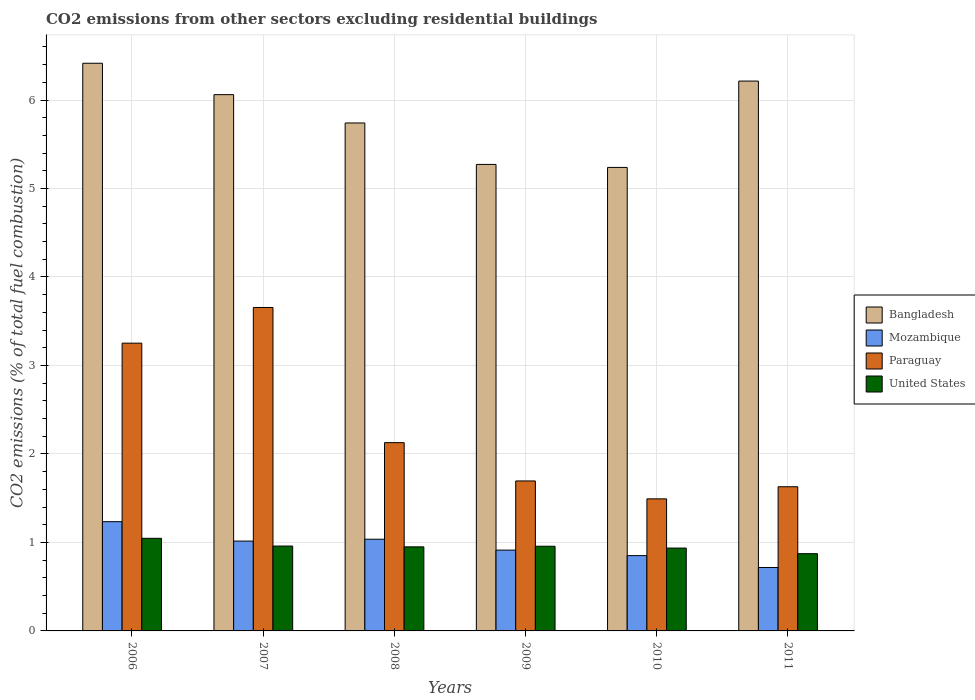How many groups of bars are there?
Give a very brief answer. 6. Are the number of bars per tick equal to the number of legend labels?
Make the answer very short. Yes. What is the label of the 1st group of bars from the left?
Your answer should be very brief. 2006. In how many cases, is the number of bars for a given year not equal to the number of legend labels?
Provide a succinct answer. 0. What is the total CO2 emitted in Bangladesh in 2010?
Your answer should be very brief. 5.24. Across all years, what is the maximum total CO2 emitted in Paraguay?
Provide a succinct answer. 3.66. Across all years, what is the minimum total CO2 emitted in Bangladesh?
Your response must be concise. 5.24. What is the total total CO2 emitted in Mozambique in the graph?
Your answer should be very brief. 5.77. What is the difference between the total CO2 emitted in Paraguay in 2007 and that in 2008?
Your answer should be compact. 1.53. What is the difference between the total CO2 emitted in Bangladesh in 2010 and the total CO2 emitted in United States in 2009?
Your response must be concise. 4.28. What is the average total CO2 emitted in Bangladesh per year?
Offer a very short reply. 5.82. In the year 2011, what is the difference between the total CO2 emitted in Bangladesh and total CO2 emitted in Paraguay?
Provide a succinct answer. 4.58. In how many years, is the total CO2 emitted in United States greater than 5?
Provide a succinct answer. 0. What is the ratio of the total CO2 emitted in Bangladesh in 2008 to that in 2009?
Give a very brief answer. 1.09. Is the total CO2 emitted in Bangladesh in 2006 less than that in 2011?
Keep it short and to the point. No. Is the difference between the total CO2 emitted in Bangladesh in 2007 and 2009 greater than the difference between the total CO2 emitted in Paraguay in 2007 and 2009?
Keep it short and to the point. No. What is the difference between the highest and the second highest total CO2 emitted in United States?
Your answer should be compact. 0.09. What is the difference between the highest and the lowest total CO2 emitted in United States?
Offer a terse response. 0.17. Is it the case that in every year, the sum of the total CO2 emitted in United States and total CO2 emitted in Paraguay is greater than the sum of total CO2 emitted in Bangladesh and total CO2 emitted in Mozambique?
Your response must be concise. No. What does the 1st bar from the left in 2011 represents?
Make the answer very short. Bangladesh. What does the 3rd bar from the right in 2007 represents?
Offer a very short reply. Mozambique. Is it the case that in every year, the sum of the total CO2 emitted in Paraguay and total CO2 emitted in Bangladesh is greater than the total CO2 emitted in Mozambique?
Your answer should be very brief. Yes. How many years are there in the graph?
Ensure brevity in your answer.  6. Are the values on the major ticks of Y-axis written in scientific E-notation?
Give a very brief answer. No. Does the graph contain grids?
Your answer should be very brief. Yes. How are the legend labels stacked?
Offer a very short reply. Vertical. What is the title of the graph?
Make the answer very short. CO2 emissions from other sectors excluding residential buildings. Does "Sao Tome and Principe" appear as one of the legend labels in the graph?
Offer a terse response. No. What is the label or title of the X-axis?
Keep it short and to the point. Years. What is the label or title of the Y-axis?
Give a very brief answer. CO2 emissions (% of total fuel combustion). What is the CO2 emissions (% of total fuel combustion) in Bangladesh in 2006?
Give a very brief answer. 6.42. What is the CO2 emissions (% of total fuel combustion) of Mozambique in 2006?
Give a very brief answer. 1.23. What is the CO2 emissions (% of total fuel combustion) in Paraguay in 2006?
Make the answer very short. 3.25. What is the CO2 emissions (% of total fuel combustion) of United States in 2006?
Provide a succinct answer. 1.05. What is the CO2 emissions (% of total fuel combustion) in Bangladesh in 2007?
Give a very brief answer. 6.06. What is the CO2 emissions (% of total fuel combustion) in Mozambique in 2007?
Your response must be concise. 1.02. What is the CO2 emissions (% of total fuel combustion) in Paraguay in 2007?
Keep it short and to the point. 3.66. What is the CO2 emissions (% of total fuel combustion) of United States in 2007?
Ensure brevity in your answer.  0.96. What is the CO2 emissions (% of total fuel combustion) in Bangladesh in 2008?
Offer a terse response. 5.74. What is the CO2 emissions (% of total fuel combustion) in Mozambique in 2008?
Ensure brevity in your answer.  1.04. What is the CO2 emissions (% of total fuel combustion) in Paraguay in 2008?
Your answer should be very brief. 2.13. What is the CO2 emissions (% of total fuel combustion) in United States in 2008?
Keep it short and to the point. 0.95. What is the CO2 emissions (% of total fuel combustion) in Bangladesh in 2009?
Ensure brevity in your answer.  5.27. What is the CO2 emissions (% of total fuel combustion) of Mozambique in 2009?
Ensure brevity in your answer.  0.91. What is the CO2 emissions (% of total fuel combustion) in Paraguay in 2009?
Your answer should be compact. 1.69. What is the CO2 emissions (% of total fuel combustion) in United States in 2009?
Make the answer very short. 0.96. What is the CO2 emissions (% of total fuel combustion) in Bangladesh in 2010?
Offer a very short reply. 5.24. What is the CO2 emissions (% of total fuel combustion) of Mozambique in 2010?
Provide a succinct answer. 0.85. What is the CO2 emissions (% of total fuel combustion) in Paraguay in 2010?
Your answer should be compact. 1.49. What is the CO2 emissions (% of total fuel combustion) of United States in 2010?
Keep it short and to the point. 0.94. What is the CO2 emissions (% of total fuel combustion) in Bangladesh in 2011?
Keep it short and to the point. 6.21. What is the CO2 emissions (% of total fuel combustion) of Mozambique in 2011?
Your response must be concise. 0.72. What is the CO2 emissions (% of total fuel combustion) in Paraguay in 2011?
Give a very brief answer. 1.63. What is the CO2 emissions (% of total fuel combustion) in United States in 2011?
Offer a terse response. 0.87. Across all years, what is the maximum CO2 emissions (% of total fuel combustion) in Bangladesh?
Provide a succinct answer. 6.42. Across all years, what is the maximum CO2 emissions (% of total fuel combustion) in Mozambique?
Offer a very short reply. 1.23. Across all years, what is the maximum CO2 emissions (% of total fuel combustion) in Paraguay?
Give a very brief answer. 3.66. Across all years, what is the maximum CO2 emissions (% of total fuel combustion) in United States?
Provide a succinct answer. 1.05. Across all years, what is the minimum CO2 emissions (% of total fuel combustion) of Bangladesh?
Keep it short and to the point. 5.24. Across all years, what is the minimum CO2 emissions (% of total fuel combustion) of Mozambique?
Offer a very short reply. 0.72. Across all years, what is the minimum CO2 emissions (% of total fuel combustion) in Paraguay?
Give a very brief answer. 1.49. Across all years, what is the minimum CO2 emissions (% of total fuel combustion) of United States?
Make the answer very short. 0.87. What is the total CO2 emissions (% of total fuel combustion) in Bangladesh in the graph?
Give a very brief answer. 34.94. What is the total CO2 emissions (% of total fuel combustion) in Mozambique in the graph?
Offer a very short reply. 5.77. What is the total CO2 emissions (% of total fuel combustion) of Paraguay in the graph?
Keep it short and to the point. 13.85. What is the total CO2 emissions (% of total fuel combustion) in United States in the graph?
Give a very brief answer. 5.72. What is the difference between the CO2 emissions (% of total fuel combustion) in Bangladesh in 2006 and that in 2007?
Your answer should be very brief. 0.35. What is the difference between the CO2 emissions (% of total fuel combustion) in Mozambique in 2006 and that in 2007?
Provide a succinct answer. 0.22. What is the difference between the CO2 emissions (% of total fuel combustion) in Paraguay in 2006 and that in 2007?
Your answer should be very brief. -0.4. What is the difference between the CO2 emissions (% of total fuel combustion) of United States in 2006 and that in 2007?
Your answer should be very brief. 0.09. What is the difference between the CO2 emissions (% of total fuel combustion) of Bangladesh in 2006 and that in 2008?
Your answer should be very brief. 0.67. What is the difference between the CO2 emissions (% of total fuel combustion) in Mozambique in 2006 and that in 2008?
Provide a succinct answer. 0.2. What is the difference between the CO2 emissions (% of total fuel combustion) of Paraguay in 2006 and that in 2008?
Give a very brief answer. 1.12. What is the difference between the CO2 emissions (% of total fuel combustion) of United States in 2006 and that in 2008?
Provide a succinct answer. 0.1. What is the difference between the CO2 emissions (% of total fuel combustion) of Bangladesh in 2006 and that in 2009?
Provide a succinct answer. 1.14. What is the difference between the CO2 emissions (% of total fuel combustion) in Mozambique in 2006 and that in 2009?
Your answer should be very brief. 0.32. What is the difference between the CO2 emissions (% of total fuel combustion) in Paraguay in 2006 and that in 2009?
Make the answer very short. 1.56. What is the difference between the CO2 emissions (% of total fuel combustion) in United States in 2006 and that in 2009?
Make the answer very short. 0.09. What is the difference between the CO2 emissions (% of total fuel combustion) in Bangladesh in 2006 and that in 2010?
Give a very brief answer. 1.18. What is the difference between the CO2 emissions (% of total fuel combustion) in Mozambique in 2006 and that in 2010?
Your response must be concise. 0.38. What is the difference between the CO2 emissions (% of total fuel combustion) in Paraguay in 2006 and that in 2010?
Ensure brevity in your answer.  1.76. What is the difference between the CO2 emissions (% of total fuel combustion) in United States in 2006 and that in 2010?
Your answer should be compact. 0.11. What is the difference between the CO2 emissions (% of total fuel combustion) of Bangladesh in 2006 and that in 2011?
Ensure brevity in your answer.  0.2. What is the difference between the CO2 emissions (% of total fuel combustion) in Mozambique in 2006 and that in 2011?
Your response must be concise. 0.52. What is the difference between the CO2 emissions (% of total fuel combustion) of Paraguay in 2006 and that in 2011?
Your answer should be very brief. 1.62. What is the difference between the CO2 emissions (% of total fuel combustion) in United States in 2006 and that in 2011?
Keep it short and to the point. 0.17. What is the difference between the CO2 emissions (% of total fuel combustion) in Bangladesh in 2007 and that in 2008?
Provide a succinct answer. 0.32. What is the difference between the CO2 emissions (% of total fuel combustion) in Mozambique in 2007 and that in 2008?
Your answer should be very brief. -0.02. What is the difference between the CO2 emissions (% of total fuel combustion) in Paraguay in 2007 and that in 2008?
Make the answer very short. 1.53. What is the difference between the CO2 emissions (% of total fuel combustion) in United States in 2007 and that in 2008?
Keep it short and to the point. 0.01. What is the difference between the CO2 emissions (% of total fuel combustion) in Bangladesh in 2007 and that in 2009?
Offer a terse response. 0.79. What is the difference between the CO2 emissions (% of total fuel combustion) of Mozambique in 2007 and that in 2009?
Your answer should be very brief. 0.1. What is the difference between the CO2 emissions (% of total fuel combustion) of Paraguay in 2007 and that in 2009?
Make the answer very short. 1.96. What is the difference between the CO2 emissions (% of total fuel combustion) in United States in 2007 and that in 2009?
Give a very brief answer. 0. What is the difference between the CO2 emissions (% of total fuel combustion) of Bangladesh in 2007 and that in 2010?
Provide a short and direct response. 0.82. What is the difference between the CO2 emissions (% of total fuel combustion) of Mozambique in 2007 and that in 2010?
Your answer should be very brief. 0.16. What is the difference between the CO2 emissions (% of total fuel combustion) of Paraguay in 2007 and that in 2010?
Your answer should be very brief. 2.16. What is the difference between the CO2 emissions (% of total fuel combustion) in United States in 2007 and that in 2010?
Make the answer very short. 0.02. What is the difference between the CO2 emissions (% of total fuel combustion) in Bangladesh in 2007 and that in 2011?
Make the answer very short. -0.15. What is the difference between the CO2 emissions (% of total fuel combustion) of Mozambique in 2007 and that in 2011?
Your answer should be very brief. 0.3. What is the difference between the CO2 emissions (% of total fuel combustion) of Paraguay in 2007 and that in 2011?
Your response must be concise. 2.03. What is the difference between the CO2 emissions (% of total fuel combustion) in United States in 2007 and that in 2011?
Make the answer very short. 0.09. What is the difference between the CO2 emissions (% of total fuel combustion) of Bangladesh in 2008 and that in 2009?
Your answer should be very brief. 0.47. What is the difference between the CO2 emissions (% of total fuel combustion) of Mozambique in 2008 and that in 2009?
Ensure brevity in your answer.  0.12. What is the difference between the CO2 emissions (% of total fuel combustion) in Paraguay in 2008 and that in 2009?
Your response must be concise. 0.43. What is the difference between the CO2 emissions (% of total fuel combustion) in United States in 2008 and that in 2009?
Provide a short and direct response. -0.01. What is the difference between the CO2 emissions (% of total fuel combustion) of Bangladesh in 2008 and that in 2010?
Keep it short and to the point. 0.5. What is the difference between the CO2 emissions (% of total fuel combustion) in Mozambique in 2008 and that in 2010?
Your answer should be very brief. 0.19. What is the difference between the CO2 emissions (% of total fuel combustion) of Paraguay in 2008 and that in 2010?
Your answer should be compact. 0.64. What is the difference between the CO2 emissions (% of total fuel combustion) in United States in 2008 and that in 2010?
Make the answer very short. 0.01. What is the difference between the CO2 emissions (% of total fuel combustion) in Bangladesh in 2008 and that in 2011?
Your response must be concise. -0.47. What is the difference between the CO2 emissions (% of total fuel combustion) in Mozambique in 2008 and that in 2011?
Your answer should be compact. 0.32. What is the difference between the CO2 emissions (% of total fuel combustion) of Paraguay in 2008 and that in 2011?
Offer a very short reply. 0.5. What is the difference between the CO2 emissions (% of total fuel combustion) in United States in 2008 and that in 2011?
Keep it short and to the point. 0.08. What is the difference between the CO2 emissions (% of total fuel combustion) in Bangladesh in 2009 and that in 2010?
Your answer should be compact. 0.03. What is the difference between the CO2 emissions (% of total fuel combustion) of Mozambique in 2009 and that in 2010?
Keep it short and to the point. 0.06. What is the difference between the CO2 emissions (% of total fuel combustion) of Paraguay in 2009 and that in 2010?
Offer a very short reply. 0.2. What is the difference between the CO2 emissions (% of total fuel combustion) in United States in 2009 and that in 2010?
Offer a very short reply. 0.02. What is the difference between the CO2 emissions (% of total fuel combustion) in Bangladesh in 2009 and that in 2011?
Your answer should be very brief. -0.94. What is the difference between the CO2 emissions (% of total fuel combustion) in Mozambique in 2009 and that in 2011?
Ensure brevity in your answer.  0.2. What is the difference between the CO2 emissions (% of total fuel combustion) in Paraguay in 2009 and that in 2011?
Ensure brevity in your answer.  0.07. What is the difference between the CO2 emissions (% of total fuel combustion) in United States in 2009 and that in 2011?
Ensure brevity in your answer.  0.08. What is the difference between the CO2 emissions (% of total fuel combustion) in Bangladesh in 2010 and that in 2011?
Your answer should be very brief. -0.98. What is the difference between the CO2 emissions (% of total fuel combustion) of Mozambique in 2010 and that in 2011?
Provide a short and direct response. 0.13. What is the difference between the CO2 emissions (% of total fuel combustion) of Paraguay in 2010 and that in 2011?
Your answer should be very brief. -0.14. What is the difference between the CO2 emissions (% of total fuel combustion) in United States in 2010 and that in 2011?
Provide a short and direct response. 0.06. What is the difference between the CO2 emissions (% of total fuel combustion) in Bangladesh in 2006 and the CO2 emissions (% of total fuel combustion) in Mozambique in 2007?
Provide a short and direct response. 5.4. What is the difference between the CO2 emissions (% of total fuel combustion) of Bangladesh in 2006 and the CO2 emissions (% of total fuel combustion) of Paraguay in 2007?
Offer a very short reply. 2.76. What is the difference between the CO2 emissions (% of total fuel combustion) in Bangladesh in 2006 and the CO2 emissions (% of total fuel combustion) in United States in 2007?
Offer a terse response. 5.46. What is the difference between the CO2 emissions (% of total fuel combustion) in Mozambique in 2006 and the CO2 emissions (% of total fuel combustion) in Paraguay in 2007?
Ensure brevity in your answer.  -2.42. What is the difference between the CO2 emissions (% of total fuel combustion) of Mozambique in 2006 and the CO2 emissions (% of total fuel combustion) of United States in 2007?
Your answer should be very brief. 0.28. What is the difference between the CO2 emissions (% of total fuel combustion) in Paraguay in 2006 and the CO2 emissions (% of total fuel combustion) in United States in 2007?
Provide a short and direct response. 2.29. What is the difference between the CO2 emissions (% of total fuel combustion) in Bangladesh in 2006 and the CO2 emissions (% of total fuel combustion) in Mozambique in 2008?
Offer a terse response. 5.38. What is the difference between the CO2 emissions (% of total fuel combustion) in Bangladesh in 2006 and the CO2 emissions (% of total fuel combustion) in Paraguay in 2008?
Keep it short and to the point. 4.29. What is the difference between the CO2 emissions (% of total fuel combustion) of Bangladesh in 2006 and the CO2 emissions (% of total fuel combustion) of United States in 2008?
Your response must be concise. 5.47. What is the difference between the CO2 emissions (% of total fuel combustion) in Mozambique in 2006 and the CO2 emissions (% of total fuel combustion) in Paraguay in 2008?
Your answer should be compact. -0.89. What is the difference between the CO2 emissions (% of total fuel combustion) in Mozambique in 2006 and the CO2 emissions (% of total fuel combustion) in United States in 2008?
Offer a very short reply. 0.28. What is the difference between the CO2 emissions (% of total fuel combustion) in Paraguay in 2006 and the CO2 emissions (% of total fuel combustion) in United States in 2008?
Ensure brevity in your answer.  2.3. What is the difference between the CO2 emissions (% of total fuel combustion) in Bangladesh in 2006 and the CO2 emissions (% of total fuel combustion) in Mozambique in 2009?
Your response must be concise. 5.5. What is the difference between the CO2 emissions (% of total fuel combustion) in Bangladesh in 2006 and the CO2 emissions (% of total fuel combustion) in Paraguay in 2009?
Make the answer very short. 4.72. What is the difference between the CO2 emissions (% of total fuel combustion) in Bangladesh in 2006 and the CO2 emissions (% of total fuel combustion) in United States in 2009?
Offer a terse response. 5.46. What is the difference between the CO2 emissions (% of total fuel combustion) in Mozambique in 2006 and the CO2 emissions (% of total fuel combustion) in Paraguay in 2009?
Give a very brief answer. -0.46. What is the difference between the CO2 emissions (% of total fuel combustion) in Mozambique in 2006 and the CO2 emissions (% of total fuel combustion) in United States in 2009?
Provide a succinct answer. 0.28. What is the difference between the CO2 emissions (% of total fuel combustion) of Paraguay in 2006 and the CO2 emissions (% of total fuel combustion) of United States in 2009?
Make the answer very short. 2.3. What is the difference between the CO2 emissions (% of total fuel combustion) of Bangladesh in 2006 and the CO2 emissions (% of total fuel combustion) of Mozambique in 2010?
Offer a terse response. 5.56. What is the difference between the CO2 emissions (% of total fuel combustion) of Bangladesh in 2006 and the CO2 emissions (% of total fuel combustion) of Paraguay in 2010?
Offer a terse response. 4.92. What is the difference between the CO2 emissions (% of total fuel combustion) in Bangladesh in 2006 and the CO2 emissions (% of total fuel combustion) in United States in 2010?
Keep it short and to the point. 5.48. What is the difference between the CO2 emissions (% of total fuel combustion) of Mozambique in 2006 and the CO2 emissions (% of total fuel combustion) of Paraguay in 2010?
Provide a succinct answer. -0.26. What is the difference between the CO2 emissions (% of total fuel combustion) of Mozambique in 2006 and the CO2 emissions (% of total fuel combustion) of United States in 2010?
Offer a terse response. 0.3. What is the difference between the CO2 emissions (% of total fuel combustion) of Paraguay in 2006 and the CO2 emissions (% of total fuel combustion) of United States in 2010?
Your answer should be compact. 2.32. What is the difference between the CO2 emissions (% of total fuel combustion) of Bangladesh in 2006 and the CO2 emissions (% of total fuel combustion) of Mozambique in 2011?
Ensure brevity in your answer.  5.7. What is the difference between the CO2 emissions (% of total fuel combustion) in Bangladesh in 2006 and the CO2 emissions (% of total fuel combustion) in Paraguay in 2011?
Keep it short and to the point. 4.79. What is the difference between the CO2 emissions (% of total fuel combustion) of Bangladesh in 2006 and the CO2 emissions (% of total fuel combustion) of United States in 2011?
Make the answer very short. 5.54. What is the difference between the CO2 emissions (% of total fuel combustion) of Mozambique in 2006 and the CO2 emissions (% of total fuel combustion) of Paraguay in 2011?
Offer a terse response. -0.39. What is the difference between the CO2 emissions (% of total fuel combustion) of Mozambique in 2006 and the CO2 emissions (% of total fuel combustion) of United States in 2011?
Keep it short and to the point. 0.36. What is the difference between the CO2 emissions (% of total fuel combustion) in Paraguay in 2006 and the CO2 emissions (% of total fuel combustion) in United States in 2011?
Provide a succinct answer. 2.38. What is the difference between the CO2 emissions (% of total fuel combustion) in Bangladesh in 2007 and the CO2 emissions (% of total fuel combustion) in Mozambique in 2008?
Keep it short and to the point. 5.02. What is the difference between the CO2 emissions (% of total fuel combustion) in Bangladesh in 2007 and the CO2 emissions (% of total fuel combustion) in Paraguay in 2008?
Offer a terse response. 3.93. What is the difference between the CO2 emissions (% of total fuel combustion) in Bangladesh in 2007 and the CO2 emissions (% of total fuel combustion) in United States in 2008?
Your answer should be very brief. 5.11. What is the difference between the CO2 emissions (% of total fuel combustion) in Mozambique in 2007 and the CO2 emissions (% of total fuel combustion) in Paraguay in 2008?
Your answer should be compact. -1.11. What is the difference between the CO2 emissions (% of total fuel combustion) of Mozambique in 2007 and the CO2 emissions (% of total fuel combustion) of United States in 2008?
Keep it short and to the point. 0.07. What is the difference between the CO2 emissions (% of total fuel combustion) of Paraguay in 2007 and the CO2 emissions (% of total fuel combustion) of United States in 2008?
Your response must be concise. 2.71. What is the difference between the CO2 emissions (% of total fuel combustion) of Bangladesh in 2007 and the CO2 emissions (% of total fuel combustion) of Mozambique in 2009?
Ensure brevity in your answer.  5.15. What is the difference between the CO2 emissions (% of total fuel combustion) of Bangladesh in 2007 and the CO2 emissions (% of total fuel combustion) of Paraguay in 2009?
Give a very brief answer. 4.37. What is the difference between the CO2 emissions (% of total fuel combustion) of Bangladesh in 2007 and the CO2 emissions (% of total fuel combustion) of United States in 2009?
Make the answer very short. 5.1. What is the difference between the CO2 emissions (% of total fuel combustion) in Mozambique in 2007 and the CO2 emissions (% of total fuel combustion) in Paraguay in 2009?
Your response must be concise. -0.68. What is the difference between the CO2 emissions (% of total fuel combustion) in Mozambique in 2007 and the CO2 emissions (% of total fuel combustion) in United States in 2009?
Your answer should be compact. 0.06. What is the difference between the CO2 emissions (% of total fuel combustion) of Paraguay in 2007 and the CO2 emissions (% of total fuel combustion) of United States in 2009?
Your answer should be very brief. 2.7. What is the difference between the CO2 emissions (% of total fuel combustion) of Bangladesh in 2007 and the CO2 emissions (% of total fuel combustion) of Mozambique in 2010?
Provide a short and direct response. 5.21. What is the difference between the CO2 emissions (% of total fuel combustion) in Bangladesh in 2007 and the CO2 emissions (% of total fuel combustion) in Paraguay in 2010?
Ensure brevity in your answer.  4.57. What is the difference between the CO2 emissions (% of total fuel combustion) of Bangladesh in 2007 and the CO2 emissions (% of total fuel combustion) of United States in 2010?
Make the answer very short. 5.12. What is the difference between the CO2 emissions (% of total fuel combustion) of Mozambique in 2007 and the CO2 emissions (% of total fuel combustion) of Paraguay in 2010?
Provide a succinct answer. -0.48. What is the difference between the CO2 emissions (% of total fuel combustion) of Mozambique in 2007 and the CO2 emissions (% of total fuel combustion) of United States in 2010?
Ensure brevity in your answer.  0.08. What is the difference between the CO2 emissions (% of total fuel combustion) of Paraguay in 2007 and the CO2 emissions (% of total fuel combustion) of United States in 2010?
Offer a terse response. 2.72. What is the difference between the CO2 emissions (% of total fuel combustion) in Bangladesh in 2007 and the CO2 emissions (% of total fuel combustion) in Mozambique in 2011?
Your answer should be compact. 5.34. What is the difference between the CO2 emissions (% of total fuel combustion) in Bangladesh in 2007 and the CO2 emissions (% of total fuel combustion) in Paraguay in 2011?
Make the answer very short. 4.43. What is the difference between the CO2 emissions (% of total fuel combustion) of Bangladesh in 2007 and the CO2 emissions (% of total fuel combustion) of United States in 2011?
Offer a terse response. 5.19. What is the difference between the CO2 emissions (% of total fuel combustion) in Mozambique in 2007 and the CO2 emissions (% of total fuel combustion) in Paraguay in 2011?
Your answer should be compact. -0.61. What is the difference between the CO2 emissions (% of total fuel combustion) of Mozambique in 2007 and the CO2 emissions (% of total fuel combustion) of United States in 2011?
Offer a terse response. 0.14. What is the difference between the CO2 emissions (% of total fuel combustion) of Paraguay in 2007 and the CO2 emissions (% of total fuel combustion) of United States in 2011?
Ensure brevity in your answer.  2.78. What is the difference between the CO2 emissions (% of total fuel combustion) in Bangladesh in 2008 and the CO2 emissions (% of total fuel combustion) in Mozambique in 2009?
Offer a terse response. 4.83. What is the difference between the CO2 emissions (% of total fuel combustion) in Bangladesh in 2008 and the CO2 emissions (% of total fuel combustion) in Paraguay in 2009?
Make the answer very short. 4.05. What is the difference between the CO2 emissions (% of total fuel combustion) of Bangladesh in 2008 and the CO2 emissions (% of total fuel combustion) of United States in 2009?
Provide a short and direct response. 4.78. What is the difference between the CO2 emissions (% of total fuel combustion) of Mozambique in 2008 and the CO2 emissions (% of total fuel combustion) of Paraguay in 2009?
Give a very brief answer. -0.66. What is the difference between the CO2 emissions (% of total fuel combustion) of Mozambique in 2008 and the CO2 emissions (% of total fuel combustion) of United States in 2009?
Your response must be concise. 0.08. What is the difference between the CO2 emissions (% of total fuel combustion) in Paraguay in 2008 and the CO2 emissions (% of total fuel combustion) in United States in 2009?
Provide a succinct answer. 1.17. What is the difference between the CO2 emissions (% of total fuel combustion) in Bangladesh in 2008 and the CO2 emissions (% of total fuel combustion) in Mozambique in 2010?
Provide a short and direct response. 4.89. What is the difference between the CO2 emissions (% of total fuel combustion) of Bangladesh in 2008 and the CO2 emissions (% of total fuel combustion) of Paraguay in 2010?
Ensure brevity in your answer.  4.25. What is the difference between the CO2 emissions (% of total fuel combustion) in Bangladesh in 2008 and the CO2 emissions (% of total fuel combustion) in United States in 2010?
Make the answer very short. 4.8. What is the difference between the CO2 emissions (% of total fuel combustion) of Mozambique in 2008 and the CO2 emissions (% of total fuel combustion) of Paraguay in 2010?
Make the answer very short. -0.46. What is the difference between the CO2 emissions (% of total fuel combustion) in Mozambique in 2008 and the CO2 emissions (% of total fuel combustion) in United States in 2010?
Your response must be concise. 0.1. What is the difference between the CO2 emissions (% of total fuel combustion) of Paraguay in 2008 and the CO2 emissions (% of total fuel combustion) of United States in 2010?
Provide a succinct answer. 1.19. What is the difference between the CO2 emissions (% of total fuel combustion) in Bangladesh in 2008 and the CO2 emissions (% of total fuel combustion) in Mozambique in 2011?
Offer a very short reply. 5.02. What is the difference between the CO2 emissions (% of total fuel combustion) of Bangladesh in 2008 and the CO2 emissions (% of total fuel combustion) of Paraguay in 2011?
Your answer should be compact. 4.11. What is the difference between the CO2 emissions (% of total fuel combustion) in Bangladesh in 2008 and the CO2 emissions (% of total fuel combustion) in United States in 2011?
Your answer should be very brief. 4.87. What is the difference between the CO2 emissions (% of total fuel combustion) in Mozambique in 2008 and the CO2 emissions (% of total fuel combustion) in Paraguay in 2011?
Provide a short and direct response. -0.59. What is the difference between the CO2 emissions (% of total fuel combustion) in Mozambique in 2008 and the CO2 emissions (% of total fuel combustion) in United States in 2011?
Provide a short and direct response. 0.16. What is the difference between the CO2 emissions (% of total fuel combustion) in Paraguay in 2008 and the CO2 emissions (% of total fuel combustion) in United States in 2011?
Offer a very short reply. 1.25. What is the difference between the CO2 emissions (% of total fuel combustion) in Bangladesh in 2009 and the CO2 emissions (% of total fuel combustion) in Mozambique in 2010?
Provide a short and direct response. 4.42. What is the difference between the CO2 emissions (% of total fuel combustion) of Bangladesh in 2009 and the CO2 emissions (% of total fuel combustion) of Paraguay in 2010?
Your answer should be very brief. 3.78. What is the difference between the CO2 emissions (% of total fuel combustion) in Bangladesh in 2009 and the CO2 emissions (% of total fuel combustion) in United States in 2010?
Ensure brevity in your answer.  4.34. What is the difference between the CO2 emissions (% of total fuel combustion) of Mozambique in 2009 and the CO2 emissions (% of total fuel combustion) of Paraguay in 2010?
Ensure brevity in your answer.  -0.58. What is the difference between the CO2 emissions (% of total fuel combustion) of Mozambique in 2009 and the CO2 emissions (% of total fuel combustion) of United States in 2010?
Your response must be concise. -0.02. What is the difference between the CO2 emissions (% of total fuel combustion) in Paraguay in 2009 and the CO2 emissions (% of total fuel combustion) in United States in 2010?
Give a very brief answer. 0.76. What is the difference between the CO2 emissions (% of total fuel combustion) of Bangladesh in 2009 and the CO2 emissions (% of total fuel combustion) of Mozambique in 2011?
Your answer should be compact. 4.56. What is the difference between the CO2 emissions (% of total fuel combustion) in Bangladesh in 2009 and the CO2 emissions (% of total fuel combustion) in Paraguay in 2011?
Your response must be concise. 3.64. What is the difference between the CO2 emissions (% of total fuel combustion) in Bangladesh in 2009 and the CO2 emissions (% of total fuel combustion) in United States in 2011?
Your answer should be compact. 4.4. What is the difference between the CO2 emissions (% of total fuel combustion) of Mozambique in 2009 and the CO2 emissions (% of total fuel combustion) of Paraguay in 2011?
Your response must be concise. -0.72. What is the difference between the CO2 emissions (% of total fuel combustion) of Mozambique in 2009 and the CO2 emissions (% of total fuel combustion) of United States in 2011?
Make the answer very short. 0.04. What is the difference between the CO2 emissions (% of total fuel combustion) of Paraguay in 2009 and the CO2 emissions (% of total fuel combustion) of United States in 2011?
Provide a succinct answer. 0.82. What is the difference between the CO2 emissions (% of total fuel combustion) of Bangladesh in 2010 and the CO2 emissions (% of total fuel combustion) of Mozambique in 2011?
Your answer should be very brief. 4.52. What is the difference between the CO2 emissions (% of total fuel combustion) in Bangladesh in 2010 and the CO2 emissions (% of total fuel combustion) in Paraguay in 2011?
Keep it short and to the point. 3.61. What is the difference between the CO2 emissions (% of total fuel combustion) in Bangladesh in 2010 and the CO2 emissions (% of total fuel combustion) in United States in 2011?
Your answer should be very brief. 4.37. What is the difference between the CO2 emissions (% of total fuel combustion) in Mozambique in 2010 and the CO2 emissions (% of total fuel combustion) in Paraguay in 2011?
Your response must be concise. -0.78. What is the difference between the CO2 emissions (% of total fuel combustion) of Mozambique in 2010 and the CO2 emissions (% of total fuel combustion) of United States in 2011?
Offer a very short reply. -0.02. What is the difference between the CO2 emissions (% of total fuel combustion) in Paraguay in 2010 and the CO2 emissions (% of total fuel combustion) in United States in 2011?
Offer a terse response. 0.62. What is the average CO2 emissions (% of total fuel combustion) of Bangladesh per year?
Ensure brevity in your answer.  5.82. What is the average CO2 emissions (% of total fuel combustion) of Mozambique per year?
Make the answer very short. 0.96. What is the average CO2 emissions (% of total fuel combustion) of Paraguay per year?
Offer a terse response. 2.31. What is the average CO2 emissions (% of total fuel combustion) of United States per year?
Give a very brief answer. 0.95. In the year 2006, what is the difference between the CO2 emissions (% of total fuel combustion) in Bangladesh and CO2 emissions (% of total fuel combustion) in Mozambique?
Offer a terse response. 5.18. In the year 2006, what is the difference between the CO2 emissions (% of total fuel combustion) of Bangladesh and CO2 emissions (% of total fuel combustion) of Paraguay?
Make the answer very short. 3.16. In the year 2006, what is the difference between the CO2 emissions (% of total fuel combustion) of Bangladesh and CO2 emissions (% of total fuel combustion) of United States?
Provide a succinct answer. 5.37. In the year 2006, what is the difference between the CO2 emissions (% of total fuel combustion) in Mozambique and CO2 emissions (% of total fuel combustion) in Paraguay?
Ensure brevity in your answer.  -2.02. In the year 2006, what is the difference between the CO2 emissions (% of total fuel combustion) in Mozambique and CO2 emissions (% of total fuel combustion) in United States?
Offer a very short reply. 0.19. In the year 2006, what is the difference between the CO2 emissions (% of total fuel combustion) of Paraguay and CO2 emissions (% of total fuel combustion) of United States?
Your answer should be compact. 2.21. In the year 2007, what is the difference between the CO2 emissions (% of total fuel combustion) of Bangladesh and CO2 emissions (% of total fuel combustion) of Mozambique?
Offer a terse response. 5.05. In the year 2007, what is the difference between the CO2 emissions (% of total fuel combustion) in Bangladesh and CO2 emissions (% of total fuel combustion) in Paraguay?
Your answer should be compact. 2.41. In the year 2007, what is the difference between the CO2 emissions (% of total fuel combustion) in Bangladesh and CO2 emissions (% of total fuel combustion) in United States?
Your answer should be very brief. 5.1. In the year 2007, what is the difference between the CO2 emissions (% of total fuel combustion) in Mozambique and CO2 emissions (% of total fuel combustion) in Paraguay?
Your answer should be compact. -2.64. In the year 2007, what is the difference between the CO2 emissions (% of total fuel combustion) of Mozambique and CO2 emissions (% of total fuel combustion) of United States?
Offer a terse response. 0.06. In the year 2007, what is the difference between the CO2 emissions (% of total fuel combustion) in Paraguay and CO2 emissions (% of total fuel combustion) in United States?
Ensure brevity in your answer.  2.7. In the year 2008, what is the difference between the CO2 emissions (% of total fuel combustion) in Bangladesh and CO2 emissions (% of total fuel combustion) in Mozambique?
Your response must be concise. 4.7. In the year 2008, what is the difference between the CO2 emissions (% of total fuel combustion) in Bangladesh and CO2 emissions (% of total fuel combustion) in Paraguay?
Ensure brevity in your answer.  3.61. In the year 2008, what is the difference between the CO2 emissions (% of total fuel combustion) in Bangladesh and CO2 emissions (% of total fuel combustion) in United States?
Your answer should be compact. 4.79. In the year 2008, what is the difference between the CO2 emissions (% of total fuel combustion) in Mozambique and CO2 emissions (% of total fuel combustion) in Paraguay?
Ensure brevity in your answer.  -1.09. In the year 2008, what is the difference between the CO2 emissions (% of total fuel combustion) in Mozambique and CO2 emissions (% of total fuel combustion) in United States?
Provide a short and direct response. 0.09. In the year 2008, what is the difference between the CO2 emissions (% of total fuel combustion) in Paraguay and CO2 emissions (% of total fuel combustion) in United States?
Offer a terse response. 1.18. In the year 2009, what is the difference between the CO2 emissions (% of total fuel combustion) of Bangladesh and CO2 emissions (% of total fuel combustion) of Mozambique?
Give a very brief answer. 4.36. In the year 2009, what is the difference between the CO2 emissions (% of total fuel combustion) of Bangladesh and CO2 emissions (% of total fuel combustion) of Paraguay?
Keep it short and to the point. 3.58. In the year 2009, what is the difference between the CO2 emissions (% of total fuel combustion) in Bangladesh and CO2 emissions (% of total fuel combustion) in United States?
Your answer should be very brief. 4.32. In the year 2009, what is the difference between the CO2 emissions (% of total fuel combustion) of Mozambique and CO2 emissions (% of total fuel combustion) of Paraguay?
Make the answer very short. -0.78. In the year 2009, what is the difference between the CO2 emissions (% of total fuel combustion) of Mozambique and CO2 emissions (% of total fuel combustion) of United States?
Give a very brief answer. -0.04. In the year 2009, what is the difference between the CO2 emissions (% of total fuel combustion) in Paraguay and CO2 emissions (% of total fuel combustion) in United States?
Give a very brief answer. 0.74. In the year 2010, what is the difference between the CO2 emissions (% of total fuel combustion) of Bangladesh and CO2 emissions (% of total fuel combustion) of Mozambique?
Make the answer very short. 4.39. In the year 2010, what is the difference between the CO2 emissions (% of total fuel combustion) in Bangladesh and CO2 emissions (% of total fuel combustion) in Paraguay?
Your response must be concise. 3.75. In the year 2010, what is the difference between the CO2 emissions (% of total fuel combustion) in Bangladesh and CO2 emissions (% of total fuel combustion) in United States?
Offer a very short reply. 4.3. In the year 2010, what is the difference between the CO2 emissions (% of total fuel combustion) of Mozambique and CO2 emissions (% of total fuel combustion) of Paraguay?
Your answer should be very brief. -0.64. In the year 2010, what is the difference between the CO2 emissions (% of total fuel combustion) of Mozambique and CO2 emissions (% of total fuel combustion) of United States?
Offer a very short reply. -0.09. In the year 2010, what is the difference between the CO2 emissions (% of total fuel combustion) of Paraguay and CO2 emissions (% of total fuel combustion) of United States?
Offer a very short reply. 0.56. In the year 2011, what is the difference between the CO2 emissions (% of total fuel combustion) of Bangladesh and CO2 emissions (% of total fuel combustion) of Mozambique?
Keep it short and to the point. 5.5. In the year 2011, what is the difference between the CO2 emissions (% of total fuel combustion) in Bangladesh and CO2 emissions (% of total fuel combustion) in Paraguay?
Keep it short and to the point. 4.58. In the year 2011, what is the difference between the CO2 emissions (% of total fuel combustion) in Bangladesh and CO2 emissions (% of total fuel combustion) in United States?
Your response must be concise. 5.34. In the year 2011, what is the difference between the CO2 emissions (% of total fuel combustion) in Mozambique and CO2 emissions (% of total fuel combustion) in Paraguay?
Provide a succinct answer. -0.91. In the year 2011, what is the difference between the CO2 emissions (% of total fuel combustion) of Mozambique and CO2 emissions (% of total fuel combustion) of United States?
Your answer should be compact. -0.16. In the year 2011, what is the difference between the CO2 emissions (% of total fuel combustion) of Paraguay and CO2 emissions (% of total fuel combustion) of United States?
Provide a succinct answer. 0.76. What is the ratio of the CO2 emissions (% of total fuel combustion) of Bangladesh in 2006 to that in 2007?
Your answer should be compact. 1.06. What is the ratio of the CO2 emissions (% of total fuel combustion) in Mozambique in 2006 to that in 2007?
Provide a short and direct response. 1.22. What is the ratio of the CO2 emissions (% of total fuel combustion) of Paraguay in 2006 to that in 2007?
Make the answer very short. 0.89. What is the ratio of the CO2 emissions (% of total fuel combustion) in United States in 2006 to that in 2007?
Keep it short and to the point. 1.09. What is the ratio of the CO2 emissions (% of total fuel combustion) in Bangladesh in 2006 to that in 2008?
Offer a terse response. 1.12. What is the ratio of the CO2 emissions (% of total fuel combustion) in Mozambique in 2006 to that in 2008?
Provide a short and direct response. 1.19. What is the ratio of the CO2 emissions (% of total fuel combustion) in Paraguay in 2006 to that in 2008?
Give a very brief answer. 1.53. What is the ratio of the CO2 emissions (% of total fuel combustion) of United States in 2006 to that in 2008?
Make the answer very short. 1.1. What is the ratio of the CO2 emissions (% of total fuel combustion) in Bangladesh in 2006 to that in 2009?
Your answer should be very brief. 1.22. What is the ratio of the CO2 emissions (% of total fuel combustion) of Mozambique in 2006 to that in 2009?
Ensure brevity in your answer.  1.35. What is the ratio of the CO2 emissions (% of total fuel combustion) in Paraguay in 2006 to that in 2009?
Offer a very short reply. 1.92. What is the ratio of the CO2 emissions (% of total fuel combustion) of United States in 2006 to that in 2009?
Provide a short and direct response. 1.09. What is the ratio of the CO2 emissions (% of total fuel combustion) in Bangladesh in 2006 to that in 2010?
Your answer should be compact. 1.22. What is the ratio of the CO2 emissions (% of total fuel combustion) of Mozambique in 2006 to that in 2010?
Keep it short and to the point. 1.45. What is the ratio of the CO2 emissions (% of total fuel combustion) in Paraguay in 2006 to that in 2010?
Your answer should be very brief. 2.18. What is the ratio of the CO2 emissions (% of total fuel combustion) in United States in 2006 to that in 2010?
Your answer should be compact. 1.12. What is the ratio of the CO2 emissions (% of total fuel combustion) of Bangladesh in 2006 to that in 2011?
Provide a short and direct response. 1.03. What is the ratio of the CO2 emissions (% of total fuel combustion) in Mozambique in 2006 to that in 2011?
Make the answer very short. 1.72. What is the ratio of the CO2 emissions (% of total fuel combustion) of Paraguay in 2006 to that in 2011?
Give a very brief answer. 2. What is the ratio of the CO2 emissions (% of total fuel combustion) of United States in 2006 to that in 2011?
Keep it short and to the point. 1.2. What is the ratio of the CO2 emissions (% of total fuel combustion) of Bangladesh in 2007 to that in 2008?
Your answer should be very brief. 1.06. What is the ratio of the CO2 emissions (% of total fuel combustion) in Mozambique in 2007 to that in 2008?
Offer a very short reply. 0.98. What is the ratio of the CO2 emissions (% of total fuel combustion) of Paraguay in 2007 to that in 2008?
Your answer should be very brief. 1.72. What is the ratio of the CO2 emissions (% of total fuel combustion) in United States in 2007 to that in 2008?
Provide a succinct answer. 1.01. What is the ratio of the CO2 emissions (% of total fuel combustion) in Bangladesh in 2007 to that in 2009?
Give a very brief answer. 1.15. What is the ratio of the CO2 emissions (% of total fuel combustion) of Mozambique in 2007 to that in 2009?
Keep it short and to the point. 1.11. What is the ratio of the CO2 emissions (% of total fuel combustion) of Paraguay in 2007 to that in 2009?
Provide a short and direct response. 2.16. What is the ratio of the CO2 emissions (% of total fuel combustion) of Bangladesh in 2007 to that in 2010?
Keep it short and to the point. 1.16. What is the ratio of the CO2 emissions (% of total fuel combustion) in Mozambique in 2007 to that in 2010?
Offer a terse response. 1.19. What is the ratio of the CO2 emissions (% of total fuel combustion) in Paraguay in 2007 to that in 2010?
Offer a very short reply. 2.45. What is the ratio of the CO2 emissions (% of total fuel combustion) in United States in 2007 to that in 2010?
Keep it short and to the point. 1.02. What is the ratio of the CO2 emissions (% of total fuel combustion) in Bangladesh in 2007 to that in 2011?
Make the answer very short. 0.98. What is the ratio of the CO2 emissions (% of total fuel combustion) in Mozambique in 2007 to that in 2011?
Make the answer very short. 1.42. What is the ratio of the CO2 emissions (% of total fuel combustion) in Paraguay in 2007 to that in 2011?
Provide a short and direct response. 2.24. What is the ratio of the CO2 emissions (% of total fuel combustion) of United States in 2007 to that in 2011?
Offer a terse response. 1.1. What is the ratio of the CO2 emissions (% of total fuel combustion) of Bangladesh in 2008 to that in 2009?
Ensure brevity in your answer.  1.09. What is the ratio of the CO2 emissions (% of total fuel combustion) in Mozambique in 2008 to that in 2009?
Offer a terse response. 1.13. What is the ratio of the CO2 emissions (% of total fuel combustion) in Paraguay in 2008 to that in 2009?
Give a very brief answer. 1.26. What is the ratio of the CO2 emissions (% of total fuel combustion) of United States in 2008 to that in 2009?
Ensure brevity in your answer.  0.99. What is the ratio of the CO2 emissions (% of total fuel combustion) of Bangladesh in 2008 to that in 2010?
Your answer should be compact. 1.1. What is the ratio of the CO2 emissions (% of total fuel combustion) in Mozambique in 2008 to that in 2010?
Your answer should be very brief. 1.22. What is the ratio of the CO2 emissions (% of total fuel combustion) of Paraguay in 2008 to that in 2010?
Provide a succinct answer. 1.43. What is the ratio of the CO2 emissions (% of total fuel combustion) of United States in 2008 to that in 2010?
Offer a terse response. 1.01. What is the ratio of the CO2 emissions (% of total fuel combustion) of Bangladesh in 2008 to that in 2011?
Your answer should be compact. 0.92. What is the ratio of the CO2 emissions (% of total fuel combustion) of Mozambique in 2008 to that in 2011?
Give a very brief answer. 1.45. What is the ratio of the CO2 emissions (% of total fuel combustion) in Paraguay in 2008 to that in 2011?
Provide a short and direct response. 1.31. What is the ratio of the CO2 emissions (% of total fuel combustion) in United States in 2008 to that in 2011?
Make the answer very short. 1.09. What is the ratio of the CO2 emissions (% of total fuel combustion) in Bangladesh in 2009 to that in 2010?
Your response must be concise. 1.01. What is the ratio of the CO2 emissions (% of total fuel combustion) of Mozambique in 2009 to that in 2010?
Keep it short and to the point. 1.07. What is the ratio of the CO2 emissions (% of total fuel combustion) in Paraguay in 2009 to that in 2010?
Provide a short and direct response. 1.14. What is the ratio of the CO2 emissions (% of total fuel combustion) in United States in 2009 to that in 2010?
Ensure brevity in your answer.  1.02. What is the ratio of the CO2 emissions (% of total fuel combustion) in Bangladesh in 2009 to that in 2011?
Offer a very short reply. 0.85. What is the ratio of the CO2 emissions (% of total fuel combustion) in Mozambique in 2009 to that in 2011?
Give a very brief answer. 1.27. What is the ratio of the CO2 emissions (% of total fuel combustion) in Paraguay in 2009 to that in 2011?
Keep it short and to the point. 1.04. What is the ratio of the CO2 emissions (% of total fuel combustion) in United States in 2009 to that in 2011?
Provide a succinct answer. 1.1. What is the ratio of the CO2 emissions (% of total fuel combustion) of Bangladesh in 2010 to that in 2011?
Your answer should be very brief. 0.84. What is the ratio of the CO2 emissions (% of total fuel combustion) of Mozambique in 2010 to that in 2011?
Your answer should be very brief. 1.19. What is the ratio of the CO2 emissions (% of total fuel combustion) of Paraguay in 2010 to that in 2011?
Offer a very short reply. 0.92. What is the ratio of the CO2 emissions (% of total fuel combustion) in United States in 2010 to that in 2011?
Your response must be concise. 1.07. What is the difference between the highest and the second highest CO2 emissions (% of total fuel combustion) of Bangladesh?
Offer a terse response. 0.2. What is the difference between the highest and the second highest CO2 emissions (% of total fuel combustion) of Mozambique?
Give a very brief answer. 0.2. What is the difference between the highest and the second highest CO2 emissions (% of total fuel combustion) of Paraguay?
Keep it short and to the point. 0.4. What is the difference between the highest and the second highest CO2 emissions (% of total fuel combustion) of United States?
Offer a very short reply. 0.09. What is the difference between the highest and the lowest CO2 emissions (% of total fuel combustion) of Bangladesh?
Your answer should be very brief. 1.18. What is the difference between the highest and the lowest CO2 emissions (% of total fuel combustion) of Mozambique?
Make the answer very short. 0.52. What is the difference between the highest and the lowest CO2 emissions (% of total fuel combustion) in Paraguay?
Provide a succinct answer. 2.16. What is the difference between the highest and the lowest CO2 emissions (% of total fuel combustion) of United States?
Your answer should be compact. 0.17. 